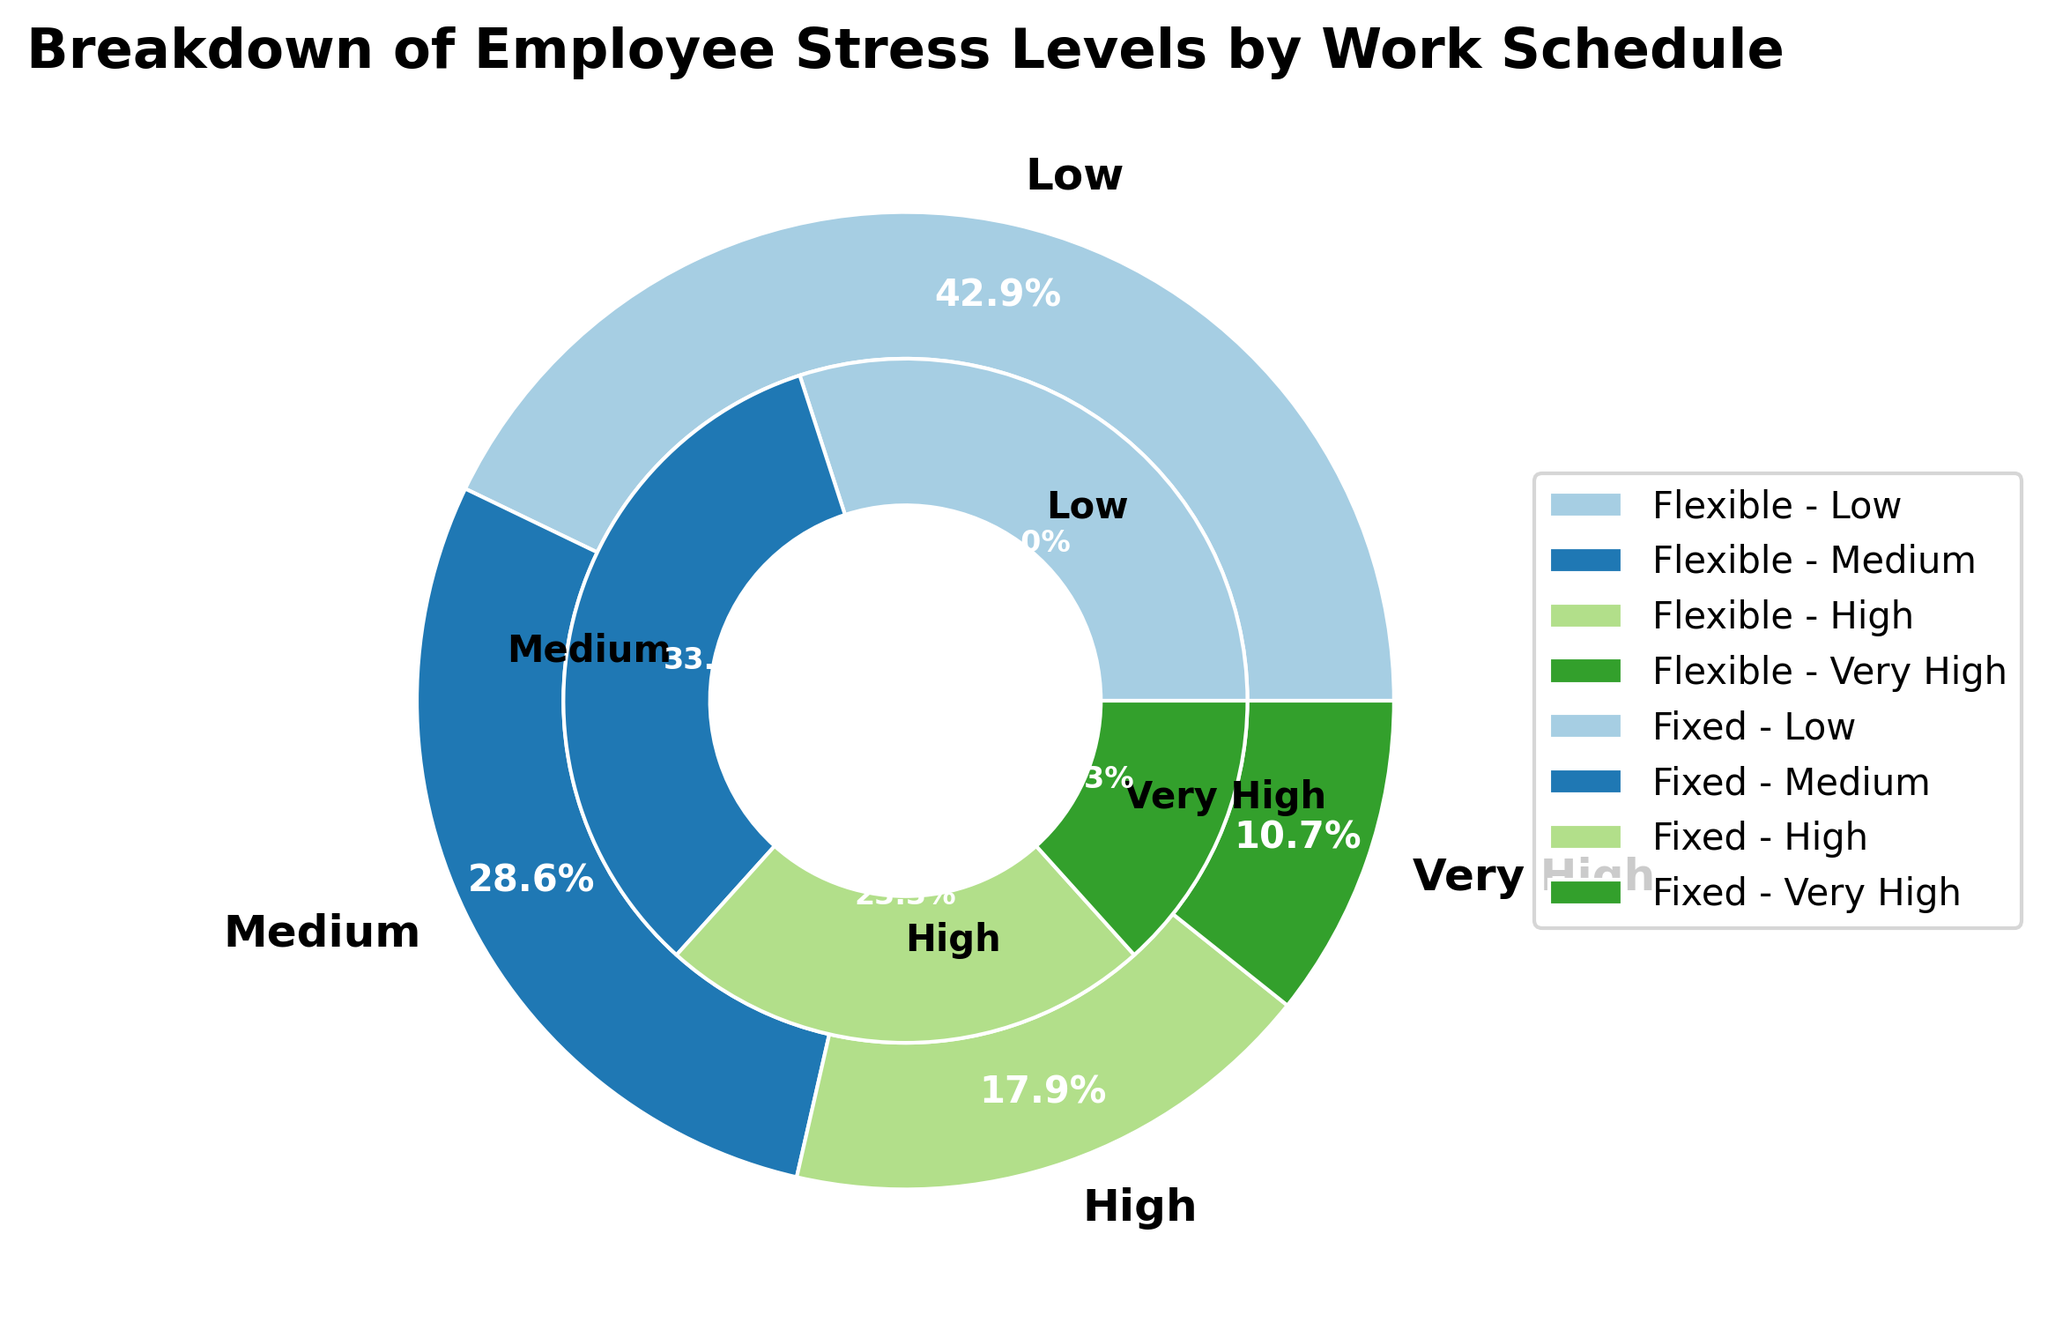What percentage of employees with a flexible schedule report low stress levels? In the ring chart, employees with a flexible schedule reporting low stress levels are indicated as 120 out of the total 280 flexible schedule employees (120 + 80 + 50 + 30 = 280). To find the percentage, divide 120 by 280 and multiply by 100: (120/280) * 100 ≈ 42.9%.
Answer: 42.9% Which stress level has the highest count for employees with a fixed schedule? The ring chart shows the distribution of stress levels for fixed-schedule employees. The segment with the largest proportion for the fixed schedule is Medium, which corresponds to a count of 100.
Answer: Medium Are there more employees with low stress levels in flexible schedules or fixed schedules? Compare the counts for low stress levels between flexible (120) and fixed (90) schedules. Since 120 is greater than 90, there are more employees with low stress levels in flexible schedules.
Answer: Flexible What is the ratio of high stress level employees between fixed and flexible schedules? Count for high stress level employees in fixed schedules is 70 and in flexible schedules is 50. The ratio is calculated by dividing 70 by 50: 70/50 = 1.4.
Answer: 1.4 How many more employees report medium stress levels in fixed schedules than in flexible schedules? Medium stress levels have counts of 100 in fixed schedules and 80 in flexible schedules. The difference is found by subtracting 80 from 100: 100 - 80 = 20.
Answer: 20 Which stress level has the smallest percentage for flexible schedule employees? For flexible schedule employees, the percentages for Very High, High, Medium, and Low are approximately 10.7%, 17.9%, 28.6%, and 42.9%, respectively. Very High has the smallest percentage (10.7%).
Answer: Very High What is the total number of employees with either high or very high stress levels across both schedules? Sum the counts of high and very high stress levels for both schedules: (Flexible: High: 50, Very High: 30) + (Fixed: High: 70, Very High: 40) = 50 + 30 + 70 + 40 = 190.
Answer: 190 What is the difference in the percentages of employees with low stress levels between flexible and fixed schedules? Calculate the percentages for low stress levels: Flexible is ~42.9% (120/280 * 100) and Fixed is ~30% (90/300 * 100). The difference is 42.9% - 30% = 12.9%.
Answer: 12.9% Among employees with a flexible schedule, what fraction has either high or very high stress levels? For flexible schedules, the count of high (50) and very high (30) stress levels is 80 out of the total 280 flexible schedule employees. The fraction is 80/280 which simplifies to 2/7.
Answer: 2/7 